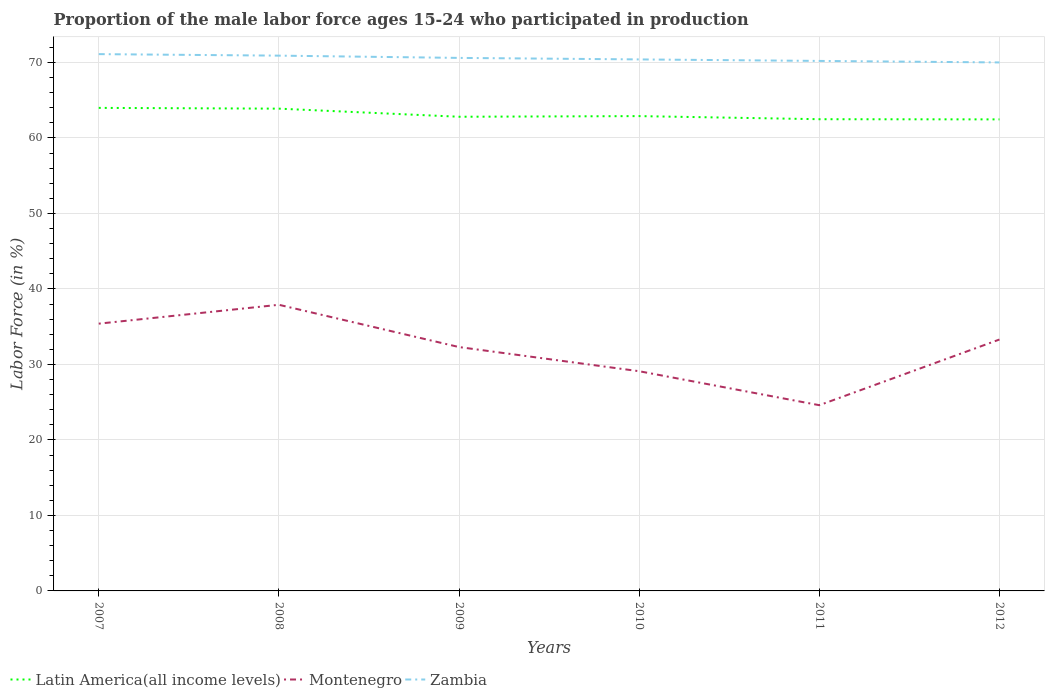How many different coloured lines are there?
Give a very brief answer. 3. In which year was the proportion of the male labor force who participated in production in Zambia maximum?
Ensure brevity in your answer.  2012. What is the total proportion of the male labor force who participated in production in Latin America(all income levels) in the graph?
Offer a very short reply. 1.09. What is the difference between the highest and the second highest proportion of the male labor force who participated in production in Montenegro?
Offer a terse response. 13.3. Is the proportion of the male labor force who participated in production in Zambia strictly greater than the proportion of the male labor force who participated in production in Montenegro over the years?
Keep it short and to the point. No. How many lines are there?
Offer a very short reply. 3. What is the difference between two consecutive major ticks on the Y-axis?
Ensure brevity in your answer.  10. Does the graph contain any zero values?
Ensure brevity in your answer.  No. How are the legend labels stacked?
Ensure brevity in your answer.  Horizontal. What is the title of the graph?
Offer a terse response. Proportion of the male labor force ages 15-24 who participated in production. What is the label or title of the Y-axis?
Provide a short and direct response. Labor Force (in %). What is the Labor Force (in %) of Latin America(all income levels) in 2007?
Make the answer very short. 63.98. What is the Labor Force (in %) in Montenegro in 2007?
Offer a terse response. 35.4. What is the Labor Force (in %) in Zambia in 2007?
Offer a very short reply. 71.1. What is the Labor Force (in %) of Latin America(all income levels) in 2008?
Your answer should be compact. 63.88. What is the Labor Force (in %) in Montenegro in 2008?
Provide a short and direct response. 37.9. What is the Labor Force (in %) in Zambia in 2008?
Give a very brief answer. 70.9. What is the Labor Force (in %) of Latin America(all income levels) in 2009?
Offer a very short reply. 62.81. What is the Labor Force (in %) in Montenegro in 2009?
Ensure brevity in your answer.  32.3. What is the Labor Force (in %) in Zambia in 2009?
Give a very brief answer. 70.6. What is the Labor Force (in %) in Latin America(all income levels) in 2010?
Make the answer very short. 62.89. What is the Labor Force (in %) in Montenegro in 2010?
Make the answer very short. 29.1. What is the Labor Force (in %) in Zambia in 2010?
Ensure brevity in your answer.  70.4. What is the Labor Force (in %) of Latin America(all income levels) in 2011?
Keep it short and to the point. 62.48. What is the Labor Force (in %) in Montenegro in 2011?
Make the answer very short. 24.6. What is the Labor Force (in %) of Zambia in 2011?
Provide a short and direct response. 70.2. What is the Labor Force (in %) in Latin America(all income levels) in 2012?
Offer a very short reply. 62.46. What is the Labor Force (in %) in Montenegro in 2012?
Give a very brief answer. 33.3. Across all years, what is the maximum Labor Force (in %) of Latin America(all income levels)?
Your response must be concise. 63.98. Across all years, what is the maximum Labor Force (in %) of Montenegro?
Your answer should be compact. 37.9. Across all years, what is the maximum Labor Force (in %) in Zambia?
Ensure brevity in your answer.  71.1. Across all years, what is the minimum Labor Force (in %) of Latin America(all income levels)?
Offer a terse response. 62.46. Across all years, what is the minimum Labor Force (in %) of Montenegro?
Your answer should be very brief. 24.6. What is the total Labor Force (in %) of Latin America(all income levels) in the graph?
Make the answer very short. 378.49. What is the total Labor Force (in %) of Montenegro in the graph?
Give a very brief answer. 192.6. What is the total Labor Force (in %) of Zambia in the graph?
Provide a short and direct response. 423.2. What is the difference between the Labor Force (in %) of Latin America(all income levels) in 2007 and that in 2008?
Provide a succinct answer. 0.1. What is the difference between the Labor Force (in %) in Montenegro in 2007 and that in 2008?
Provide a short and direct response. -2.5. What is the difference between the Labor Force (in %) of Latin America(all income levels) in 2007 and that in 2009?
Ensure brevity in your answer.  1.17. What is the difference between the Labor Force (in %) of Montenegro in 2007 and that in 2009?
Ensure brevity in your answer.  3.1. What is the difference between the Labor Force (in %) of Latin America(all income levels) in 2007 and that in 2010?
Offer a very short reply. 1.09. What is the difference between the Labor Force (in %) of Latin America(all income levels) in 2007 and that in 2011?
Give a very brief answer. 1.5. What is the difference between the Labor Force (in %) of Zambia in 2007 and that in 2011?
Your answer should be compact. 0.9. What is the difference between the Labor Force (in %) of Latin America(all income levels) in 2007 and that in 2012?
Ensure brevity in your answer.  1.52. What is the difference between the Labor Force (in %) in Latin America(all income levels) in 2008 and that in 2009?
Offer a terse response. 1.07. What is the difference between the Labor Force (in %) in Montenegro in 2008 and that in 2009?
Provide a succinct answer. 5.6. What is the difference between the Labor Force (in %) of Latin America(all income levels) in 2008 and that in 2010?
Your response must be concise. 0.99. What is the difference between the Labor Force (in %) of Montenegro in 2008 and that in 2010?
Provide a short and direct response. 8.8. What is the difference between the Labor Force (in %) of Latin America(all income levels) in 2008 and that in 2011?
Your answer should be very brief. 1.4. What is the difference between the Labor Force (in %) in Montenegro in 2008 and that in 2011?
Your response must be concise. 13.3. What is the difference between the Labor Force (in %) in Latin America(all income levels) in 2008 and that in 2012?
Offer a terse response. 1.42. What is the difference between the Labor Force (in %) in Montenegro in 2008 and that in 2012?
Give a very brief answer. 4.6. What is the difference between the Labor Force (in %) in Zambia in 2008 and that in 2012?
Provide a short and direct response. 0.9. What is the difference between the Labor Force (in %) of Latin America(all income levels) in 2009 and that in 2010?
Offer a terse response. -0.08. What is the difference between the Labor Force (in %) in Zambia in 2009 and that in 2010?
Offer a very short reply. 0.2. What is the difference between the Labor Force (in %) in Latin America(all income levels) in 2009 and that in 2011?
Make the answer very short. 0.33. What is the difference between the Labor Force (in %) in Montenegro in 2009 and that in 2011?
Ensure brevity in your answer.  7.7. What is the difference between the Labor Force (in %) in Zambia in 2009 and that in 2011?
Your response must be concise. 0.4. What is the difference between the Labor Force (in %) in Latin America(all income levels) in 2009 and that in 2012?
Offer a very short reply. 0.35. What is the difference between the Labor Force (in %) of Montenegro in 2009 and that in 2012?
Give a very brief answer. -1. What is the difference between the Labor Force (in %) in Zambia in 2009 and that in 2012?
Offer a terse response. 0.6. What is the difference between the Labor Force (in %) in Latin America(all income levels) in 2010 and that in 2011?
Ensure brevity in your answer.  0.41. What is the difference between the Labor Force (in %) of Montenegro in 2010 and that in 2011?
Your answer should be compact. 4.5. What is the difference between the Labor Force (in %) in Latin America(all income levels) in 2010 and that in 2012?
Provide a short and direct response. 0.43. What is the difference between the Labor Force (in %) of Montenegro in 2010 and that in 2012?
Make the answer very short. -4.2. What is the difference between the Labor Force (in %) of Latin America(all income levels) in 2011 and that in 2012?
Your answer should be compact. 0.02. What is the difference between the Labor Force (in %) in Zambia in 2011 and that in 2012?
Your answer should be very brief. 0.2. What is the difference between the Labor Force (in %) of Latin America(all income levels) in 2007 and the Labor Force (in %) of Montenegro in 2008?
Your response must be concise. 26.08. What is the difference between the Labor Force (in %) in Latin America(all income levels) in 2007 and the Labor Force (in %) in Zambia in 2008?
Give a very brief answer. -6.92. What is the difference between the Labor Force (in %) of Montenegro in 2007 and the Labor Force (in %) of Zambia in 2008?
Offer a terse response. -35.5. What is the difference between the Labor Force (in %) of Latin America(all income levels) in 2007 and the Labor Force (in %) of Montenegro in 2009?
Offer a very short reply. 31.68. What is the difference between the Labor Force (in %) of Latin America(all income levels) in 2007 and the Labor Force (in %) of Zambia in 2009?
Make the answer very short. -6.62. What is the difference between the Labor Force (in %) in Montenegro in 2007 and the Labor Force (in %) in Zambia in 2009?
Make the answer very short. -35.2. What is the difference between the Labor Force (in %) of Latin America(all income levels) in 2007 and the Labor Force (in %) of Montenegro in 2010?
Offer a very short reply. 34.88. What is the difference between the Labor Force (in %) of Latin America(all income levels) in 2007 and the Labor Force (in %) of Zambia in 2010?
Give a very brief answer. -6.42. What is the difference between the Labor Force (in %) in Montenegro in 2007 and the Labor Force (in %) in Zambia in 2010?
Make the answer very short. -35. What is the difference between the Labor Force (in %) in Latin America(all income levels) in 2007 and the Labor Force (in %) in Montenegro in 2011?
Ensure brevity in your answer.  39.38. What is the difference between the Labor Force (in %) of Latin America(all income levels) in 2007 and the Labor Force (in %) of Zambia in 2011?
Your answer should be compact. -6.22. What is the difference between the Labor Force (in %) in Montenegro in 2007 and the Labor Force (in %) in Zambia in 2011?
Keep it short and to the point. -34.8. What is the difference between the Labor Force (in %) in Latin America(all income levels) in 2007 and the Labor Force (in %) in Montenegro in 2012?
Give a very brief answer. 30.68. What is the difference between the Labor Force (in %) of Latin America(all income levels) in 2007 and the Labor Force (in %) of Zambia in 2012?
Make the answer very short. -6.02. What is the difference between the Labor Force (in %) of Montenegro in 2007 and the Labor Force (in %) of Zambia in 2012?
Make the answer very short. -34.6. What is the difference between the Labor Force (in %) in Latin America(all income levels) in 2008 and the Labor Force (in %) in Montenegro in 2009?
Ensure brevity in your answer.  31.58. What is the difference between the Labor Force (in %) of Latin America(all income levels) in 2008 and the Labor Force (in %) of Zambia in 2009?
Keep it short and to the point. -6.72. What is the difference between the Labor Force (in %) in Montenegro in 2008 and the Labor Force (in %) in Zambia in 2009?
Offer a terse response. -32.7. What is the difference between the Labor Force (in %) of Latin America(all income levels) in 2008 and the Labor Force (in %) of Montenegro in 2010?
Your answer should be compact. 34.78. What is the difference between the Labor Force (in %) in Latin America(all income levels) in 2008 and the Labor Force (in %) in Zambia in 2010?
Keep it short and to the point. -6.52. What is the difference between the Labor Force (in %) of Montenegro in 2008 and the Labor Force (in %) of Zambia in 2010?
Make the answer very short. -32.5. What is the difference between the Labor Force (in %) of Latin America(all income levels) in 2008 and the Labor Force (in %) of Montenegro in 2011?
Your answer should be very brief. 39.28. What is the difference between the Labor Force (in %) in Latin America(all income levels) in 2008 and the Labor Force (in %) in Zambia in 2011?
Make the answer very short. -6.32. What is the difference between the Labor Force (in %) of Montenegro in 2008 and the Labor Force (in %) of Zambia in 2011?
Provide a short and direct response. -32.3. What is the difference between the Labor Force (in %) in Latin America(all income levels) in 2008 and the Labor Force (in %) in Montenegro in 2012?
Provide a short and direct response. 30.58. What is the difference between the Labor Force (in %) of Latin America(all income levels) in 2008 and the Labor Force (in %) of Zambia in 2012?
Your response must be concise. -6.12. What is the difference between the Labor Force (in %) in Montenegro in 2008 and the Labor Force (in %) in Zambia in 2012?
Provide a succinct answer. -32.1. What is the difference between the Labor Force (in %) of Latin America(all income levels) in 2009 and the Labor Force (in %) of Montenegro in 2010?
Your answer should be compact. 33.71. What is the difference between the Labor Force (in %) in Latin America(all income levels) in 2009 and the Labor Force (in %) in Zambia in 2010?
Offer a terse response. -7.59. What is the difference between the Labor Force (in %) of Montenegro in 2009 and the Labor Force (in %) of Zambia in 2010?
Offer a terse response. -38.1. What is the difference between the Labor Force (in %) of Latin America(all income levels) in 2009 and the Labor Force (in %) of Montenegro in 2011?
Your answer should be compact. 38.21. What is the difference between the Labor Force (in %) of Latin America(all income levels) in 2009 and the Labor Force (in %) of Zambia in 2011?
Ensure brevity in your answer.  -7.39. What is the difference between the Labor Force (in %) in Montenegro in 2009 and the Labor Force (in %) in Zambia in 2011?
Provide a short and direct response. -37.9. What is the difference between the Labor Force (in %) of Latin America(all income levels) in 2009 and the Labor Force (in %) of Montenegro in 2012?
Make the answer very short. 29.51. What is the difference between the Labor Force (in %) in Latin America(all income levels) in 2009 and the Labor Force (in %) in Zambia in 2012?
Provide a short and direct response. -7.19. What is the difference between the Labor Force (in %) of Montenegro in 2009 and the Labor Force (in %) of Zambia in 2012?
Keep it short and to the point. -37.7. What is the difference between the Labor Force (in %) in Latin America(all income levels) in 2010 and the Labor Force (in %) in Montenegro in 2011?
Your response must be concise. 38.29. What is the difference between the Labor Force (in %) in Latin America(all income levels) in 2010 and the Labor Force (in %) in Zambia in 2011?
Offer a very short reply. -7.31. What is the difference between the Labor Force (in %) in Montenegro in 2010 and the Labor Force (in %) in Zambia in 2011?
Provide a succinct answer. -41.1. What is the difference between the Labor Force (in %) in Latin America(all income levels) in 2010 and the Labor Force (in %) in Montenegro in 2012?
Provide a succinct answer. 29.59. What is the difference between the Labor Force (in %) in Latin America(all income levels) in 2010 and the Labor Force (in %) in Zambia in 2012?
Provide a short and direct response. -7.11. What is the difference between the Labor Force (in %) of Montenegro in 2010 and the Labor Force (in %) of Zambia in 2012?
Offer a terse response. -40.9. What is the difference between the Labor Force (in %) of Latin America(all income levels) in 2011 and the Labor Force (in %) of Montenegro in 2012?
Your answer should be very brief. 29.18. What is the difference between the Labor Force (in %) of Latin America(all income levels) in 2011 and the Labor Force (in %) of Zambia in 2012?
Provide a short and direct response. -7.52. What is the difference between the Labor Force (in %) of Montenegro in 2011 and the Labor Force (in %) of Zambia in 2012?
Offer a very short reply. -45.4. What is the average Labor Force (in %) of Latin America(all income levels) per year?
Ensure brevity in your answer.  63.08. What is the average Labor Force (in %) of Montenegro per year?
Your answer should be compact. 32.1. What is the average Labor Force (in %) in Zambia per year?
Give a very brief answer. 70.53. In the year 2007, what is the difference between the Labor Force (in %) of Latin America(all income levels) and Labor Force (in %) of Montenegro?
Ensure brevity in your answer.  28.58. In the year 2007, what is the difference between the Labor Force (in %) in Latin America(all income levels) and Labor Force (in %) in Zambia?
Provide a succinct answer. -7.12. In the year 2007, what is the difference between the Labor Force (in %) in Montenegro and Labor Force (in %) in Zambia?
Your answer should be very brief. -35.7. In the year 2008, what is the difference between the Labor Force (in %) in Latin America(all income levels) and Labor Force (in %) in Montenegro?
Provide a succinct answer. 25.98. In the year 2008, what is the difference between the Labor Force (in %) of Latin America(all income levels) and Labor Force (in %) of Zambia?
Provide a short and direct response. -7.02. In the year 2008, what is the difference between the Labor Force (in %) in Montenegro and Labor Force (in %) in Zambia?
Ensure brevity in your answer.  -33. In the year 2009, what is the difference between the Labor Force (in %) in Latin America(all income levels) and Labor Force (in %) in Montenegro?
Your response must be concise. 30.51. In the year 2009, what is the difference between the Labor Force (in %) of Latin America(all income levels) and Labor Force (in %) of Zambia?
Give a very brief answer. -7.79. In the year 2009, what is the difference between the Labor Force (in %) in Montenegro and Labor Force (in %) in Zambia?
Ensure brevity in your answer.  -38.3. In the year 2010, what is the difference between the Labor Force (in %) of Latin America(all income levels) and Labor Force (in %) of Montenegro?
Ensure brevity in your answer.  33.79. In the year 2010, what is the difference between the Labor Force (in %) in Latin America(all income levels) and Labor Force (in %) in Zambia?
Offer a terse response. -7.51. In the year 2010, what is the difference between the Labor Force (in %) in Montenegro and Labor Force (in %) in Zambia?
Offer a terse response. -41.3. In the year 2011, what is the difference between the Labor Force (in %) of Latin America(all income levels) and Labor Force (in %) of Montenegro?
Offer a very short reply. 37.88. In the year 2011, what is the difference between the Labor Force (in %) of Latin America(all income levels) and Labor Force (in %) of Zambia?
Provide a short and direct response. -7.72. In the year 2011, what is the difference between the Labor Force (in %) of Montenegro and Labor Force (in %) of Zambia?
Make the answer very short. -45.6. In the year 2012, what is the difference between the Labor Force (in %) in Latin America(all income levels) and Labor Force (in %) in Montenegro?
Provide a succinct answer. 29.16. In the year 2012, what is the difference between the Labor Force (in %) in Latin America(all income levels) and Labor Force (in %) in Zambia?
Provide a short and direct response. -7.54. In the year 2012, what is the difference between the Labor Force (in %) in Montenegro and Labor Force (in %) in Zambia?
Provide a succinct answer. -36.7. What is the ratio of the Labor Force (in %) of Montenegro in 2007 to that in 2008?
Offer a terse response. 0.93. What is the ratio of the Labor Force (in %) in Zambia in 2007 to that in 2008?
Offer a very short reply. 1. What is the ratio of the Labor Force (in %) of Latin America(all income levels) in 2007 to that in 2009?
Offer a terse response. 1.02. What is the ratio of the Labor Force (in %) in Montenegro in 2007 to that in 2009?
Your answer should be compact. 1.1. What is the ratio of the Labor Force (in %) of Zambia in 2007 to that in 2009?
Provide a short and direct response. 1.01. What is the ratio of the Labor Force (in %) in Latin America(all income levels) in 2007 to that in 2010?
Offer a very short reply. 1.02. What is the ratio of the Labor Force (in %) in Montenegro in 2007 to that in 2010?
Make the answer very short. 1.22. What is the ratio of the Labor Force (in %) in Zambia in 2007 to that in 2010?
Make the answer very short. 1.01. What is the ratio of the Labor Force (in %) of Montenegro in 2007 to that in 2011?
Keep it short and to the point. 1.44. What is the ratio of the Labor Force (in %) of Zambia in 2007 to that in 2011?
Give a very brief answer. 1.01. What is the ratio of the Labor Force (in %) of Latin America(all income levels) in 2007 to that in 2012?
Keep it short and to the point. 1.02. What is the ratio of the Labor Force (in %) of Montenegro in 2007 to that in 2012?
Your answer should be very brief. 1.06. What is the ratio of the Labor Force (in %) of Zambia in 2007 to that in 2012?
Offer a terse response. 1.02. What is the ratio of the Labor Force (in %) in Latin America(all income levels) in 2008 to that in 2009?
Your answer should be compact. 1.02. What is the ratio of the Labor Force (in %) of Montenegro in 2008 to that in 2009?
Give a very brief answer. 1.17. What is the ratio of the Labor Force (in %) of Latin America(all income levels) in 2008 to that in 2010?
Give a very brief answer. 1.02. What is the ratio of the Labor Force (in %) in Montenegro in 2008 to that in 2010?
Make the answer very short. 1.3. What is the ratio of the Labor Force (in %) of Zambia in 2008 to that in 2010?
Keep it short and to the point. 1.01. What is the ratio of the Labor Force (in %) of Latin America(all income levels) in 2008 to that in 2011?
Your answer should be compact. 1.02. What is the ratio of the Labor Force (in %) in Montenegro in 2008 to that in 2011?
Your answer should be very brief. 1.54. What is the ratio of the Labor Force (in %) of Latin America(all income levels) in 2008 to that in 2012?
Offer a terse response. 1.02. What is the ratio of the Labor Force (in %) in Montenegro in 2008 to that in 2012?
Make the answer very short. 1.14. What is the ratio of the Labor Force (in %) in Zambia in 2008 to that in 2012?
Offer a very short reply. 1.01. What is the ratio of the Labor Force (in %) in Montenegro in 2009 to that in 2010?
Offer a very short reply. 1.11. What is the ratio of the Labor Force (in %) in Zambia in 2009 to that in 2010?
Ensure brevity in your answer.  1. What is the ratio of the Labor Force (in %) of Latin America(all income levels) in 2009 to that in 2011?
Your answer should be very brief. 1.01. What is the ratio of the Labor Force (in %) of Montenegro in 2009 to that in 2011?
Provide a succinct answer. 1.31. What is the ratio of the Labor Force (in %) in Latin America(all income levels) in 2009 to that in 2012?
Provide a short and direct response. 1.01. What is the ratio of the Labor Force (in %) of Zambia in 2009 to that in 2012?
Provide a succinct answer. 1.01. What is the ratio of the Labor Force (in %) in Latin America(all income levels) in 2010 to that in 2011?
Offer a terse response. 1.01. What is the ratio of the Labor Force (in %) in Montenegro in 2010 to that in 2011?
Provide a succinct answer. 1.18. What is the ratio of the Labor Force (in %) of Zambia in 2010 to that in 2011?
Provide a succinct answer. 1. What is the ratio of the Labor Force (in %) in Montenegro in 2010 to that in 2012?
Provide a short and direct response. 0.87. What is the ratio of the Labor Force (in %) in Latin America(all income levels) in 2011 to that in 2012?
Provide a succinct answer. 1. What is the ratio of the Labor Force (in %) of Montenegro in 2011 to that in 2012?
Your answer should be compact. 0.74. What is the ratio of the Labor Force (in %) in Zambia in 2011 to that in 2012?
Offer a terse response. 1. What is the difference between the highest and the second highest Labor Force (in %) of Latin America(all income levels)?
Make the answer very short. 0.1. What is the difference between the highest and the second highest Labor Force (in %) of Montenegro?
Offer a terse response. 2.5. What is the difference between the highest and the lowest Labor Force (in %) of Latin America(all income levels)?
Your response must be concise. 1.52. What is the difference between the highest and the lowest Labor Force (in %) in Zambia?
Make the answer very short. 1.1. 